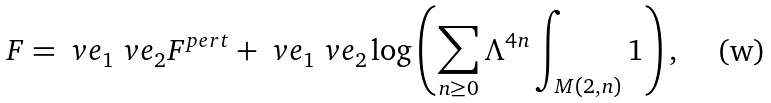Convert formula to latex. <formula><loc_0><loc_0><loc_500><loc_500>F = \ v e _ { 1 } \ v e _ { 2 } F ^ { p e r t } + \ v e _ { 1 } \ v e _ { 2 } \log \left ( \sum _ { n \geq 0 } \Lambda ^ { 4 n } \int _ { M ( 2 , n ) } 1 \right ) ,</formula> 